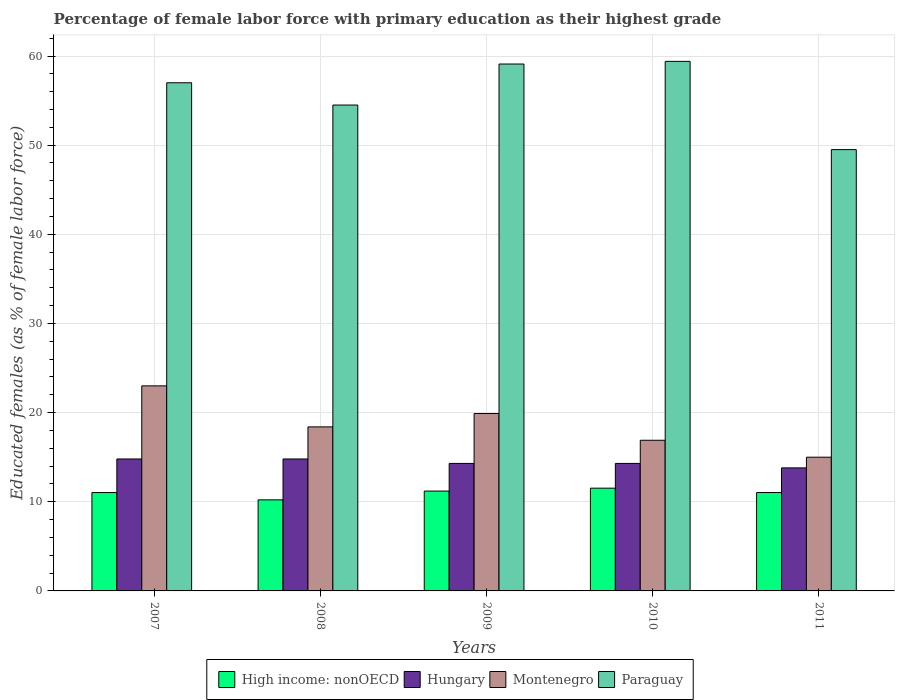How many different coloured bars are there?
Your response must be concise. 4. Are the number of bars on each tick of the X-axis equal?
Offer a very short reply. Yes. What is the label of the 5th group of bars from the left?
Your response must be concise. 2011. Across all years, what is the maximum percentage of female labor force with primary education in High income: nonOECD?
Your answer should be very brief. 11.53. Across all years, what is the minimum percentage of female labor force with primary education in Hungary?
Offer a very short reply. 13.8. In which year was the percentage of female labor force with primary education in Paraguay minimum?
Offer a terse response. 2011. What is the total percentage of female labor force with primary education in High income: nonOECD in the graph?
Your answer should be compact. 55.01. What is the difference between the percentage of female labor force with primary education in Montenegro in 2007 and that in 2010?
Keep it short and to the point. 6.1. What is the average percentage of female labor force with primary education in High income: nonOECD per year?
Provide a short and direct response. 11. In the year 2009, what is the difference between the percentage of female labor force with primary education in Paraguay and percentage of female labor force with primary education in Hungary?
Provide a succinct answer. 44.8. In how many years, is the percentage of female labor force with primary education in Paraguay greater than 20 %?
Give a very brief answer. 5. What is the ratio of the percentage of female labor force with primary education in Hungary in 2009 to that in 2011?
Make the answer very short. 1.04. Is the percentage of female labor force with primary education in High income: nonOECD in 2010 less than that in 2011?
Ensure brevity in your answer.  No. Is the difference between the percentage of female labor force with primary education in Paraguay in 2008 and 2011 greater than the difference between the percentage of female labor force with primary education in Hungary in 2008 and 2011?
Provide a succinct answer. Yes. What is the difference between the highest and the second highest percentage of female labor force with primary education in Hungary?
Your answer should be very brief. 0. What is the difference between the highest and the lowest percentage of female labor force with primary education in Hungary?
Offer a terse response. 1. What does the 2nd bar from the left in 2007 represents?
Provide a short and direct response. Hungary. What does the 4th bar from the right in 2008 represents?
Your answer should be compact. High income: nonOECD. Is it the case that in every year, the sum of the percentage of female labor force with primary education in Montenegro and percentage of female labor force with primary education in High income: nonOECD is greater than the percentage of female labor force with primary education in Hungary?
Keep it short and to the point. Yes. How many bars are there?
Offer a very short reply. 20. Are all the bars in the graph horizontal?
Give a very brief answer. No. How many years are there in the graph?
Keep it short and to the point. 5. What is the difference between two consecutive major ticks on the Y-axis?
Provide a succinct answer. 10. Are the values on the major ticks of Y-axis written in scientific E-notation?
Make the answer very short. No. Does the graph contain any zero values?
Provide a short and direct response. No. Does the graph contain grids?
Provide a succinct answer. Yes. Where does the legend appear in the graph?
Your answer should be very brief. Bottom center. How many legend labels are there?
Your answer should be very brief. 4. What is the title of the graph?
Offer a very short reply. Percentage of female labor force with primary education as their highest grade. What is the label or title of the Y-axis?
Ensure brevity in your answer.  Educated females (as % of female labor force). What is the Educated females (as % of female labor force) of High income: nonOECD in 2007?
Your answer should be very brief. 11.03. What is the Educated females (as % of female labor force) in Hungary in 2007?
Your answer should be compact. 14.8. What is the Educated females (as % of female labor force) in Montenegro in 2007?
Provide a short and direct response. 23. What is the Educated females (as % of female labor force) of High income: nonOECD in 2008?
Provide a succinct answer. 10.21. What is the Educated females (as % of female labor force) of Hungary in 2008?
Offer a very short reply. 14.8. What is the Educated females (as % of female labor force) of Montenegro in 2008?
Make the answer very short. 18.4. What is the Educated females (as % of female labor force) of Paraguay in 2008?
Provide a short and direct response. 54.5. What is the Educated females (as % of female labor force) of High income: nonOECD in 2009?
Keep it short and to the point. 11.2. What is the Educated females (as % of female labor force) in Hungary in 2009?
Your answer should be compact. 14.3. What is the Educated females (as % of female labor force) of Montenegro in 2009?
Your response must be concise. 19.9. What is the Educated females (as % of female labor force) in Paraguay in 2009?
Your response must be concise. 59.1. What is the Educated females (as % of female labor force) of High income: nonOECD in 2010?
Provide a short and direct response. 11.53. What is the Educated females (as % of female labor force) of Hungary in 2010?
Offer a very short reply. 14.3. What is the Educated females (as % of female labor force) of Montenegro in 2010?
Give a very brief answer. 16.9. What is the Educated females (as % of female labor force) of Paraguay in 2010?
Provide a short and direct response. 59.4. What is the Educated females (as % of female labor force) in High income: nonOECD in 2011?
Your answer should be very brief. 11.03. What is the Educated females (as % of female labor force) in Hungary in 2011?
Ensure brevity in your answer.  13.8. What is the Educated females (as % of female labor force) in Paraguay in 2011?
Provide a short and direct response. 49.5. Across all years, what is the maximum Educated females (as % of female labor force) in High income: nonOECD?
Make the answer very short. 11.53. Across all years, what is the maximum Educated females (as % of female labor force) of Hungary?
Offer a terse response. 14.8. Across all years, what is the maximum Educated females (as % of female labor force) in Paraguay?
Keep it short and to the point. 59.4. Across all years, what is the minimum Educated females (as % of female labor force) of High income: nonOECD?
Ensure brevity in your answer.  10.21. Across all years, what is the minimum Educated females (as % of female labor force) in Hungary?
Keep it short and to the point. 13.8. Across all years, what is the minimum Educated females (as % of female labor force) in Paraguay?
Offer a very short reply. 49.5. What is the total Educated females (as % of female labor force) of High income: nonOECD in the graph?
Ensure brevity in your answer.  55.01. What is the total Educated females (as % of female labor force) of Hungary in the graph?
Your response must be concise. 72. What is the total Educated females (as % of female labor force) of Montenegro in the graph?
Your answer should be compact. 93.2. What is the total Educated females (as % of female labor force) in Paraguay in the graph?
Give a very brief answer. 279.5. What is the difference between the Educated females (as % of female labor force) in High income: nonOECD in 2007 and that in 2008?
Ensure brevity in your answer.  0.82. What is the difference between the Educated females (as % of female labor force) in Hungary in 2007 and that in 2008?
Provide a short and direct response. 0. What is the difference between the Educated females (as % of female labor force) of High income: nonOECD in 2007 and that in 2009?
Keep it short and to the point. -0.17. What is the difference between the Educated females (as % of female labor force) in Montenegro in 2007 and that in 2009?
Your response must be concise. 3.1. What is the difference between the Educated females (as % of female labor force) of High income: nonOECD in 2007 and that in 2010?
Provide a short and direct response. -0.49. What is the difference between the Educated females (as % of female labor force) of Montenegro in 2007 and that in 2010?
Provide a short and direct response. 6.1. What is the difference between the Educated females (as % of female labor force) in High income: nonOECD in 2007 and that in 2011?
Offer a very short reply. -0. What is the difference between the Educated females (as % of female labor force) in Hungary in 2007 and that in 2011?
Provide a short and direct response. 1. What is the difference between the Educated females (as % of female labor force) in High income: nonOECD in 2008 and that in 2009?
Keep it short and to the point. -0.99. What is the difference between the Educated females (as % of female labor force) in Hungary in 2008 and that in 2009?
Make the answer very short. 0.5. What is the difference between the Educated females (as % of female labor force) of Montenegro in 2008 and that in 2009?
Make the answer very short. -1.5. What is the difference between the Educated females (as % of female labor force) of High income: nonOECD in 2008 and that in 2010?
Your answer should be very brief. -1.31. What is the difference between the Educated females (as % of female labor force) of Montenegro in 2008 and that in 2010?
Give a very brief answer. 1.5. What is the difference between the Educated females (as % of female labor force) of Paraguay in 2008 and that in 2010?
Your answer should be very brief. -4.9. What is the difference between the Educated females (as % of female labor force) in High income: nonOECD in 2008 and that in 2011?
Your response must be concise. -0.82. What is the difference between the Educated females (as % of female labor force) in Hungary in 2008 and that in 2011?
Keep it short and to the point. 1. What is the difference between the Educated females (as % of female labor force) in High income: nonOECD in 2009 and that in 2010?
Your answer should be compact. -0.33. What is the difference between the Educated females (as % of female labor force) of Montenegro in 2009 and that in 2010?
Provide a succinct answer. 3. What is the difference between the Educated females (as % of female labor force) of Paraguay in 2009 and that in 2010?
Your answer should be compact. -0.3. What is the difference between the Educated females (as % of female labor force) in High income: nonOECD in 2009 and that in 2011?
Your answer should be very brief. 0.17. What is the difference between the Educated females (as % of female labor force) in High income: nonOECD in 2010 and that in 2011?
Keep it short and to the point. 0.49. What is the difference between the Educated females (as % of female labor force) in Hungary in 2010 and that in 2011?
Offer a terse response. 0.5. What is the difference between the Educated females (as % of female labor force) of High income: nonOECD in 2007 and the Educated females (as % of female labor force) of Hungary in 2008?
Offer a very short reply. -3.77. What is the difference between the Educated females (as % of female labor force) of High income: nonOECD in 2007 and the Educated females (as % of female labor force) of Montenegro in 2008?
Provide a succinct answer. -7.37. What is the difference between the Educated females (as % of female labor force) of High income: nonOECD in 2007 and the Educated females (as % of female labor force) of Paraguay in 2008?
Provide a succinct answer. -43.47. What is the difference between the Educated females (as % of female labor force) in Hungary in 2007 and the Educated females (as % of female labor force) in Montenegro in 2008?
Your response must be concise. -3.6. What is the difference between the Educated females (as % of female labor force) in Hungary in 2007 and the Educated females (as % of female labor force) in Paraguay in 2008?
Provide a short and direct response. -39.7. What is the difference between the Educated females (as % of female labor force) of Montenegro in 2007 and the Educated females (as % of female labor force) of Paraguay in 2008?
Keep it short and to the point. -31.5. What is the difference between the Educated females (as % of female labor force) of High income: nonOECD in 2007 and the Educated females (as % of female labor force) of Hungary in 2009?
Your answer should be very brief. -3.27. What is the difference between the Educated females (as % of female labor force) of High income: nonOECD in 2007 and the Educated females (as % of female labor force) of Montenegro in 2009?
Ensure brevity in your answer.  -8.87. What is the difference between the Educated females (as % of female labor force) of High income: nonOECD in 2007 and the Educated females (as % of female labor force) of Paraguay in 2009?
Make the answer very short. -48.07. What is the difference between the Educated females (as % of female labor force) of Hungary in 2007 and the Educated females (as % of female labor force) of Montenegro in 2009?
Keep it short and to the point. -5.1. What is the difference between the Educated females (as % of female labor force) of Hungary in 2007 and the Educated females (as % of female labor force) of Paraguay in 2009?
Keep it short and to the point. -44.3. What is the difference between the Educated females (as % of female labor force) in Montenegro in 2007 and the Educated females (as % of female labor force) in Paraguay in 2009?
Keep it short and to the point. -36.1. What is the difference between the Educated females (as % of female labor force) in High income: nonOECD in 2007 and the Educated females (as % of female labor force) in Hungary in 2010?
Your response must be concise. -3.27. What is the difference between the Educated females (as % of female labor force) in High income: nonOECD in 2007 and the Educated females (as % of female labor force) in Montenegro in 2010?
Keep it short and to the point. -5.87. What is the difference between the Educated females (as % of female labor force) of High income: nonOECD in 2007 and the Educated females (as % of female labor force) of Paraguay in 2010?
Keep it short and to the point. -48.37. What is the difference between the Educated females (as % of female labor force) of Hungary in 2007 and the Educated females (as % of female labor force) of Paraguay in 2010?
Give a very brief answer. -44.6. What is the difference between the Educated females (as % of female labor force) in Montenegro in 2007 and the Educated females (as % of female labor force) in Paraguay in 2010?
Give a very brief answer. -36.4. What is the difference between the Educated females (as % of female labor force) in High income: nonOECD in 2007 and the Educated females (as % of female labor force) in Hungary in 2011?
Ensure brevity in your answer.  -2.77. What is the difference between the Educated females (as % of female labor force) of High income: nonOECD in 2007 and the Educated females (as % of female labor force) of Montenegro in 2011?
Your response must be concise. -3.97. What is the difference between the Educated females (as % of female labor force) in High income: nonOECD in 2007 and the Educated females (as % of female labor force) in Paraguay in 2011?
Your answer should be very brief. -38.47. What is the difference between the Educated females (as % of female labor force) in Hungary in 2007 and the Educated females (as % of female labor force) in Montenegro in 2011?
Provide a short and direct response. -0.2. What is the difference between the Educated females (as % of female labor force) of Hungary in 2007 and the Educated females (as % of female labor force) of Paraguay in 2011?
Offer a very short reply. -34.7. What is the difference between the Educated females (as % of female labor force) of Montenegro in 2007 and the Educated females (as % of female labor force) of Paraguay in 2011?
Your answer should be very brief. -26.5. What is the difference between the Educated females (as % of female labor force) in High income: nonOECD in 2008 and the Educated females (as % of female labor force) in Hungary in 2009?
Offer a very short reply. -4.09. What is the difference between the Educated females (as % of female labor force) in High income: nonOECD in 2008 and the Educated females (as % of female labor force) in Montenegro in 2009?
Offer a terse response. -9.69. What is the difference between the Educated females (as % of female labor force) in High income: nonOECD in 2008 and the Educated females (as % of female labor force) in Paraguay in 2009?
Provide a short and direct response. -48.89. What is the difference between the Educated females (as % of female labor force) of Hungary in 2008 and the Educated females (as % of female labor force) of Montenegro in 2009?
Make the answer very short. -5.1. What is the difference between the Educated females (as % of female labor force) of Hungary in 2008 and the Educated females (as % of female labor force) of Paraguay in 2009?
Your answer should be very brief. -44.3. What is the difference between the Educated females (as % of female labor force) in Montenegro in 2008 and the Educated females (as % of female labor force) in Paraguay in 2009?
Keep it short and to the point. -40.7. What is the difference between the Educated females (as % of female labor force) in High income: nonOECD in 2008 and the Educated females (as % of female labor force) in Hungary in 2010?
Provide a short and direct response. -4.09. What is the difference between the Educated females (as % of female labor force) of High income: nonOECD in 2008 and the Educated females (as % of female labor force) of Montenegro in 2010?
Make the answer very short. -6.69. What is the difference between the Educated females (as % of female labor force) in High income: nonOECD in 2008 and the Educated females (as % of female labor force) in Paraguay in 2010?
Provide a short and direct response. -49.19. What is the difference between the Educated females (as % of female labor force) in Hungary in 2008 and the Educated females (as % of female labor force) in Paraguay in 2010?
Provide a succinct answer. -44.6. What is the difference between the Educated females (as % of female labor force) of Montenegro in 2008 and the Educated females (as % of female labor force) of Paraguay in 2010?
Offer a very short reply. -41. What is the difference between the Educated females (as % of female labor force) of High income: nonOECD in 2008 and the Educated females (as % of female labor force) of Hungary in 2011?
Offer a very short reply. -3.59. What is the difference between the Educated females (as % of female labor force) of High income: nonOECD in 2008 and the Educated females (as % of female labor force) of Montenegro in 2011?
Provide a succinct answer. -4.79. What is the difference between the Educated females (as % of female labor force) in High income: nonOECD in 2008 and the Educated females (as % of female labor force) in Paraguay in 2011?
Provide a short and direct response. -39.29. What is the difference between the Educated females (as % of female labor force) in Hungary in 2008 and the Educated females (as % of female labor force) in Paraguay in 2011?
Offer a very short reply. -34.7. What is the difference between the Educated females (as % of female labor force) of Montenegro in 2008 and the Educated females (as % of female labor force) of Paraguay in 2011?
Keep it short and to the point. -31.1. What is the difference between the Educated females (as % of female labor force) in High income: nonOECD in 2009 and the Educated females (as % of female labor force) in Hungary in 2010?
Provide a short and direct response. -3.1. What is the difference between the Educated females (as % of female labor force) of High income: nonOECD in 2009 and the Educated females (as % of female labor force) of Montenegro in 2010?
Make the answer very short. -5.7. What is the difference between the Educated females (as % of female labor force) in High income: nonOECD in 2009 and the Educated females (as % of female labor force) in Paraguay in 2010?
Ensure brevity in your answer.  -48.2. What is the difference between the Educated females (as % of female labor force) in Hungary in 2009 and the Educated females (as % of female labor force) in Paraguay in 2010?
Give a very brief answer. -45.1. What is the difference between the Educated females (as % of female labor force) in Montenegro in 2009 and the Educated females (as % of female labor force) in Paraguay in 2010?
Ensure brevity in your answer.  -39.5. What is the difference between the Educated females (as % of female labor force) in High income: nonOECD in 2009 and the Educated females (as % of female labor force) in Hungary in 2011?
Ensure brevity in your answer.  -2.6. What is the difference between the Educated females (as % of female labor force) in High income: nonOECD in 2009 and the Educated females (as % of female labor force) in Montenegro in 2011?
Give a very brief answer. -3.8. What is the difference between the Educated females (as % of female labor force) in High income: nonOECD in 2009 and the Educated females (as % of female labor force) in Paraguay in 2011?
Your response must be concise. -38.3. What is the difference between the Educated females (as % of female labor force) of Hungary in 2009 and the Educated females (as % of female labor force) of Paraguay in 2011?
Your answer should be compact. -35.2. What is the difference between the Educated females (as % of female labor force) in Montenegro in 2009 and the Educated females (as % of female labor force) in Paraguay in 2011?
Ensure brevity in your answer.  -29.6. What is the difference between the Educated females (as % of female labor force) in High income: nonOECD in 2010 and the Educated females (as % of female labor force) in Hungary in 2011?
Provide a short and direct response. -2.27. What is the difference between the Educated females (as % of female labor force) of High income: nonOECD in 2010 and the Educated females (as % of female labor force) of Montenegro in 2011?
Your answer should be very brief. -3.47. What is the difference between the Educated females (as % of female labor force) in High income: nonOECD in 2010 and the Educated females (as % of female labor force) in Paraguay in 2011?
Your answer should be compact. -37.97. What is the difference between the Educated females (as % of female labor force) in Hungary in 2010 and the Educated females (as % of female labor force) in Paraguay in 2011?
Make the answer very short. -35.2. What is the difference between the Educated females (as % of female labor force) of Montenegro in 2010 and the Educated females (as % of female labor force) of Paraguay in 2011?
Ensure brevity in your answer.  -32.6. What is the average Educated females (as % of female labor force) of High income: nonOECD per year?
Keep it short and to the point. 11. What is the average Educated females (as % of female labor force) of Hungary per year?
Your answer should be compact. 14.4. What is the average Educated females (as % of female labor force) of Montenegro per year?
Provide a succinct answer. 18.64. What is the average Educated females (as % of female labor force) in Paraguay per year?
Provide a succinct answer. 55.9. In the year 2007, what is the difference between the Educated females (as % of female labor force) in High income: nonOECD and Educated females (as % of female labor force) in Hungary?
Ensure brevity in your answer.  -3.77. In the year 2007, what is the difference between the Educated females (as % of female labor force) of High income: nonOECD and Educated females (as % of female labor force) of Montenegro?
Keep it short and to the point. -11.97. In the year 2007, what is the difference between the Educated females (as % of female labor force) in High income: nonOECD and Educated females (as % of female labor force) in Paraguay?
Your response must be concise. -45.97. In the year 2007, what is the difference between the Educated females (as % of female labor force) of Hungary and Educated females (as % of female labor force) of Paraguay?
Offer a very short reply. -42.2. In the year 2007, what is the difference between the Educated females (as % of female labor force) of Montenegro and Educated females (as % of female labor force) of Paraguay?
Keep it short and to the point. -34. In the year 2008, what is the difference between the Educated females (as % of female labor force) in High income: nonOECD and Educated females (as % of female labor force) in Hungary?
Offer a very short reply. -4.59. In the year 2008, what is the difference between the Educated females (as % of female labor force) in High income: nonOECD and Educated females (as % of female labor force) in Montenegro?
Your answer should be very brief. -8.19. In the year 2008, what is the difference between the Educated females (as % of female labor force) in High income: nonOECD and Educated females (as % of female labor force) in Paraguay?
Provide a succinct answer. -44.29. In the year 2008, what is the difference between the Educated females (as % of female labor force) of Hungary and Educated females (as % of female labor force) of Montenegro?
Your answer should be compact. -3.6. In the year 2008, what is the difference between the Educated females (as % of female labor force) of Hungary and Educated females (as % of female labor force) of Paraguay?
Your response must be concise. -39.7. In the year 2008, what is the difference between the Educated females (as % of female labor force) in Montenegro and Educated females (as % of female labor force) in Paraguay?
Keep it short and to the point. -36.1. In the year 2009, what is the difference between the Educated females (as % of female labor force) of High income: nonOECD and Educated females (as % of female labor force) of Hungary?
Ensure brevity in your answer.  -3.1. In the year 2009, what is the difference between the Educated females (as % of female labor force) of High income: nonOECD and Educated females (as % of female labor force) of Montenegro?
Your answer should be very brief. -8.7. In the year 2009, what is the difference between the Educated females (as % of female labor force) in High income: nonOECD and Educated females (as % of female labor force) in Paraguay?
Give a very brief answer. -47.9. In the year 2009, what is the difference between the Educated females (as % of female labor force) in Hungary and Educated females (as % of female labor force) in Paraguay?
Offer a very short reply. -44.8. In the year 2009, what is the difference between the Educated females (as % of female labor force) in Montenegro and Educated females (as % of female labor force) in Paraguay?
Your answer should be very brief. -39.2. In the year 2010, what is the difference between the Educated females (as % of female labor force) in High income: nonOECD and Educated females (as % of female labor force) in Hungary?
Offer a terse response. -2.77. In the year 2010, what is the difference between the Educated females (as % of female labor force) of High income: nonOECD and Educated females (as % of female labor force) of Montenegro?
Your answer should be very brief. -5.37. In the year 2010, what is the difference between the Educated females (as % of female labor force) in High income: nonOECD and Educated females (as % of female labor force) in Paraguay?
Provide a succinct answer. -47.87. In the year 2010, what is the difference between the Educated females (as % of female labor force) in Hungary and Educated females (as % of female labor force) in Paraguay?
Ensure brevity in your answer.  -45.1. In the year 2010, what is the difference between the Educated females (as % of female labor force) of Montenegro and Educated females (as % of female labor force) of Paraguay?
Your response must be concise. -42.5. In the year 2011, what is the difference between the Educated females (as % of female labor force) in High income: nonOECD and Educated females (as % of female labor force) in Hungary?
Your answer should be very brief. -2.77. In the year 2011, what is the difference between the Educated females (as % of female labor force) in High income: nonOECD and Educated females (as % of female labor force) in Montenegro?
Ensure brevity in your answer.  -3.97. In the year 2011, what is the difference between the Educated females (as % of female labor force) of High income: nonOECD and Educated females (as % of female labor force) of Paraguay?
Give a very brief answer. -38.47. In the year 2011, what is the difference between the Educated females (as % of female labor force) of Hungary and Educated females (as % of female labor force) of Paraguay?
Keep it short and to the point. -35.7. In the year 2011, what is the difference between the Educated females (as % of female labor force) of Montenegro and Educated females (as % of female labor force) of Paraguay?
Offer a very short reply. -34.5. What is the ratio of the Educated females (as % of female labor force) in High income: nonOECD in 2007 to that in 2008?
Keep it short and to the point. 1.08. What is the ratio of the Educated females (as % of female labor force) of Paraguay in 2007 to that in 2008?
Provide a short and direct response. 1.05. What is the ratio of the Educated females (as % of female labor force) of Hungary in 2007 to that in 2009?
Keep it short and to the point. 1.03. What is the ratio of the Educated females (as % of female labor force) of Montenegro in 2007 to that in 2009?
Your response must be concise. 1.16. What is the ratio of the Educated females (as % of female labor force) of Paraguay in 2007 to that in 2009?
Keep it short and to the point. 0.96. What is the ratio of the Educated females (as % of female labor force) in High income: nonOECD in 2007 to that in 2010?
Offer a very short reply. 0.96. What is the ratio of the Educated females (as % of female labor force) of Hungary in 2007 to that in 2010?
Provide a short and direct response. 1.03. What is the ratio of the Educated females (as % of female labor force) of Montenegro in 2007 to that in 2010?
Offer a terse response. 1.36. What is the ratio of the Educated females (as % of female labor force) in Paraguay in 2007 to that in 2010?
Keep it short and to the point. 0.96. What is the ratio of the Educated females (as % of female labor force) of Hungary in 2007 to that in 2011?
Give a very brief answer. 1.07. What is the ratio of the Educated females (as % of female labor force) of Montenegro in 2007 to that in 2011?
Make the answer very short. 1.53. What is the ratio of the Educated females (as % of female labor force) of Paraguay in 2007 to that in 2011?
Your response must be concise. 1.15. What is the ratio of the Educated females (as % of female labor force) in High income: nonOECD in 2008 to that in 2009?
Provide a short and direct response. 0.91. What is the ratio of the Educated females (as % of female labor force) of Hungary in 2008 to that in 2009?
Offer a very short reply. 1.03. What is the ratio of the Educated females (as % of female labor force) in Montenegro in 2008 to that in 2009?
Offer a very short reply. 0.92. What is the ratio of the Educated females (as % of female labor force) in Paraguay in 2008 to that in 2009?
Provide a succinct answer. 0.92. What is the ratio of the Educated females (as % of female labor force) in High income: nonOECD in 2008 to that in 2010?
Your response must be concise. 0.89. What is the ratio of the Educated females (as % of female labor force) in Hungary in 2008 to that in 2010?
Your answer should be very brief. 1.03. What is the ratio of the Educated females (as % of female labor force) of Montenegro in 2008 to that in 2010?
Your response must be concise. 1.09. What is the ratio of the Educated females (as % of female labor force) of Paraguay in 2008 to that in 2010?
Your answer should be very brief. 0.92. What is the ratio of the Educated females (as % of female labor force) of High income: nonOECD in 2008 to that in 2011?
Offer a very short reply. 0.93. What is the ratio of the Educated females (as % of female labor force) of Hungary in 2008 to that in 2011?
Keep it short and to the point. 1.07. What is the ratio of the Educated females (as % of female labor force) of Montenegro in 2008 to that in 2011?
Keep it short and to the point. 1.23. What is the ratio of the Educated females (as % of female labor force) in Paraguay in 2008 to that in 2011?
Provide a succinct answer. 1.1. What is the ratio of the Educated females (as % of female labor force) of High income: nonOECD in 2009 to that in 2010?
Make the answer very short. 0.97. What is the ratio of the Educated females (as % of female labor force) of Montenegro in 2009 to that in 2010?
Ensure brevity in your answer.  1.18. What is the ratio of the Educated females (as % of female labor force) of High income: nonOECD in 2009 to that in 2011?
Your answer should be compact. 1.01. What is the ratio of the Educated females (as % of female labor force) of Hungary in 2009 to that in 2011?
Keep it short and to the point. 1.04. What is the ratio of the Educated females (as % of female labor force) of Montenegro in 2009 to that in 2011?
Provide a succinct answer. 1.33. What is the ratio of the Educated females (as % of female labor force) in Paraguay in 2009 to that in 2011?
Your answer should be very brief. 1.19. What is the ratio of the Educated females (as % of female labor force) in High income: nonOECD in 2010 to that in 2011?
Your answer should be compact. 1.04. What is the ratio of the Educated females (as % of female labor force) in Hungary in 2010 to that in 2011?
Keep it short and to the point. 1.04. What is the ratio of the Educated females (as % of female labor force) of Montenegro in 2010 to that in 2011?
Keep it short and to the point. 1.13. What is the difference between the highest and the second highest Educated females (as % of female labor force) of High income: nonOECD?
Provide a short and direct response. 0.33. What is the difference between the highest and the second highest Educated females (as % of female labor force) of Hungary?
Your answer should be very brief. 0. What is the difference between the highest and the second highest Educated females (as % of female labor force) of Montenegro?
Offer a terse response. 3.1. What is the difference between the highest and the lowest Educated females (as % of female labor force) of High income: nonOECD?
Offer a terse response. 1.31. What is the difference between the highest and the lowest Educated females (as % of female labor force) in Hungary?
Provide a short and direct response. 1. What is the difference between the highest and the lowest Educated females (as % of female labor force) of Montenegro?
Offer a very short reply. 8. What is the difference between the highest and the lowest Educated females (as % of female labor force) in Paraguay?
Your response must be concise. 9.9. 